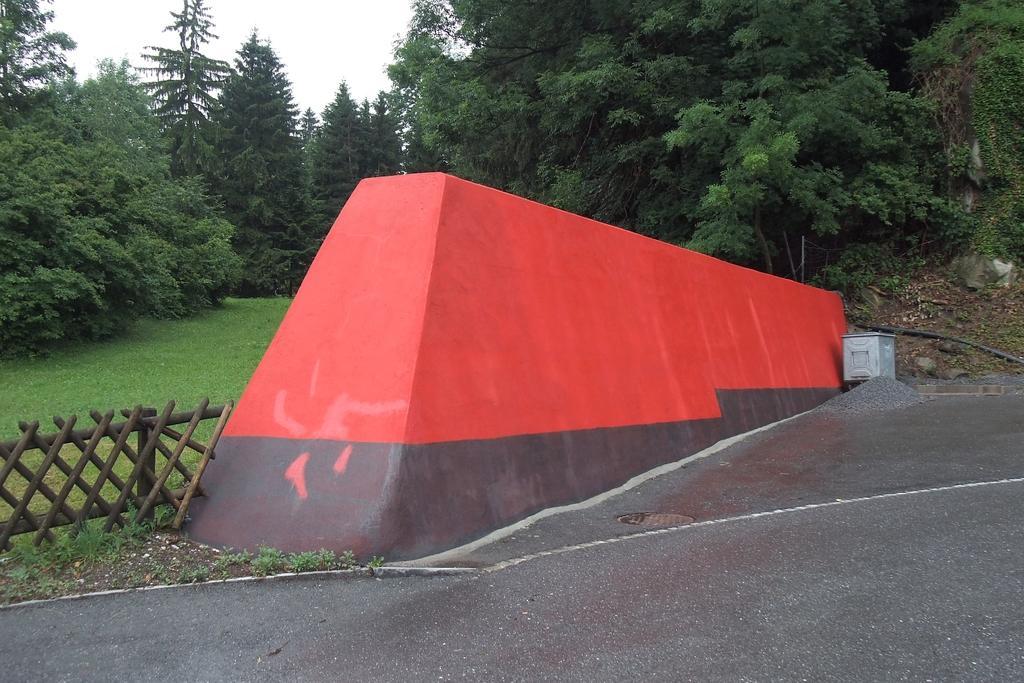Could you give a brief overview of what you see in this image? This image is taken outdoors. At the bottom of the image there is a ground. At the top of the image there is the sky. In the background there are many trees with leaves, stems and branches. There is a ground with grass on it. On the left side of the image there is a wooden fence. In the middle of the image there is a wall. 